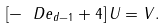Convert formula to latex. <formula><loc_0><loc_0><loc_500><loc_500>\left [ - \ D e _ { d - 1 } + 4 \right ] U = V .</formula> 